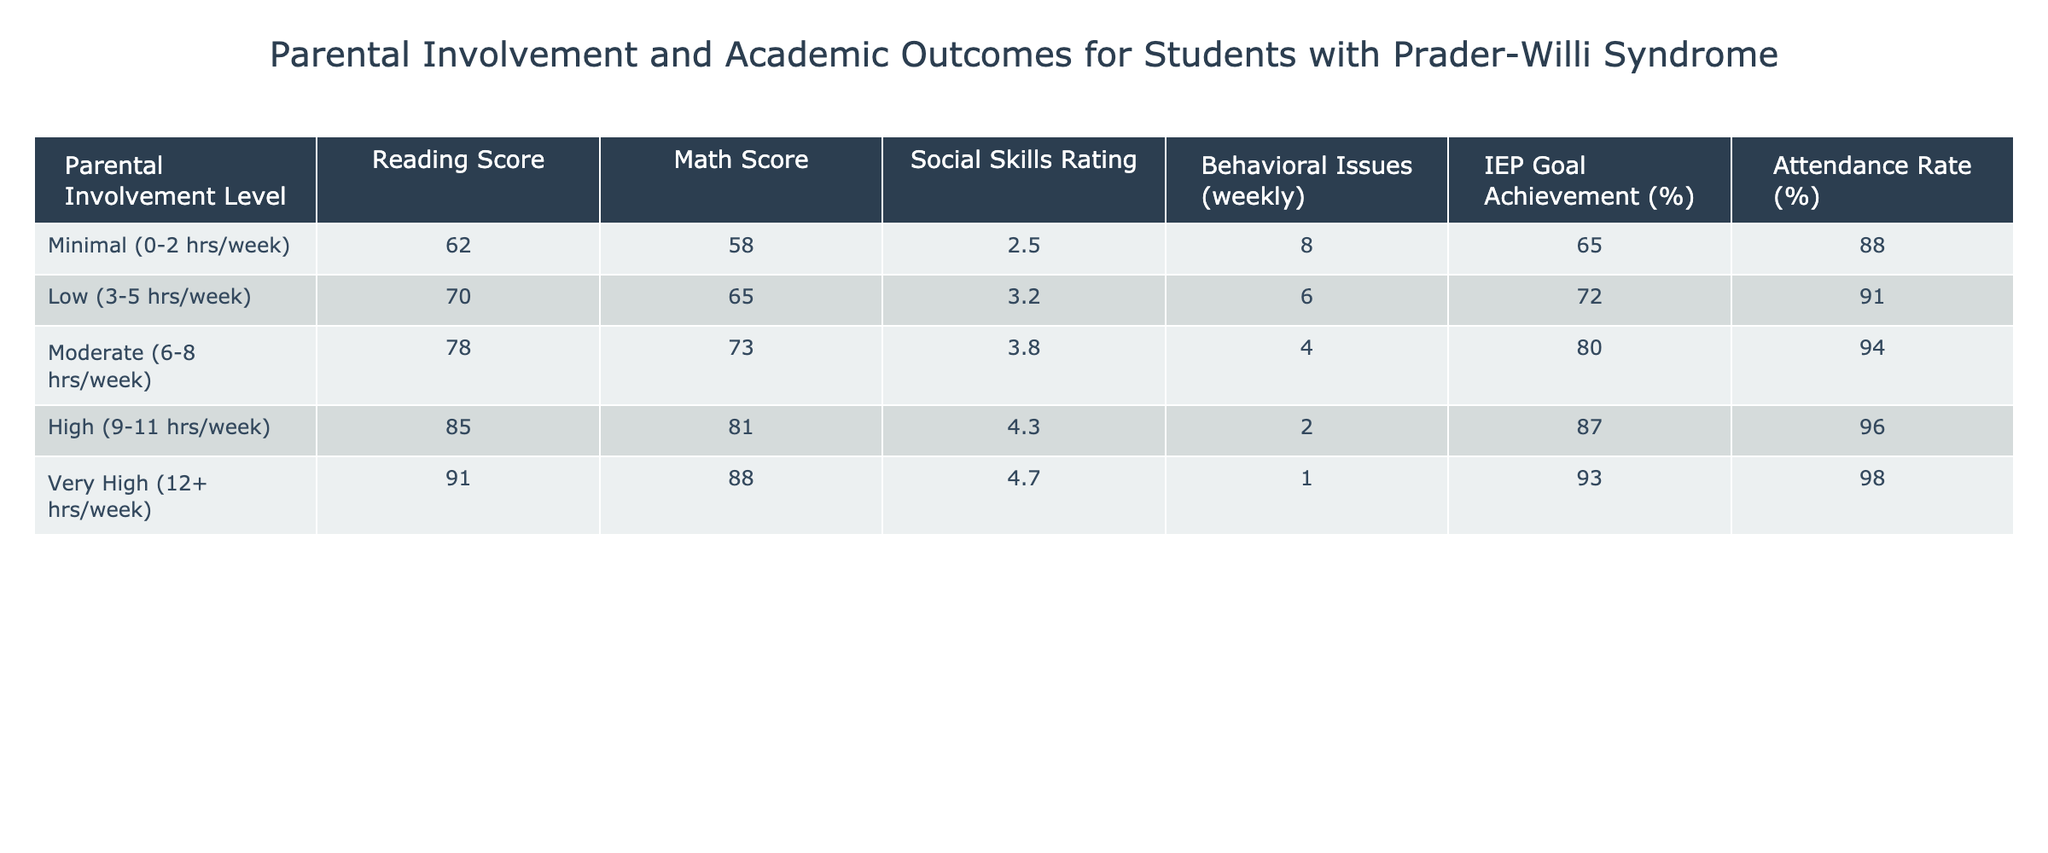What is the Reading Score for the High Parental Involvement Level? The Reading Score corresponding to the High Parental Involvement Level is listed directly in the table, which shows a score of 85.
Answer: 85 How much does the Math Score increase from Moderate to Very High Parental Involvement? The Math Score for Moderate is 73 and for Very High is 88. The difference is 88 - 73 = 15.
Answer: 15 What is the Social Skills Rating for students with Minimal Parental Involvement? According to the table, the Social Skills Rating for students with Minimal Parental Involvement is 2.5.
Answer: 2.5 Is the Attendance Rate higher for students with Very High Parental Involvement compared to those with Minimal Parental Involvement? The Attendance Rate for Very High is 98%, and for Minimal it is 88%. Since 98% is greater than 88%, the statement is true.
Answer: Yes What is the average IEP Goal Achievement percentage for students with High and Very High Parental Involvement? The IEP Goal Achievement percentage for High is 87% and for Very High is 93%. The average is (87 + 93) / 2 = 90%.
Answer: 90% Which level of Parental Involvement has the lowest Behavioral Issues and what is the value? The lowest Behavioral Issues are reported at the Very High Parental Involvement level, with a count of 1 issue weekly.
Answer: 1 By how much does the Social Skills Rating improve as Parental Involvement increases from Low to High? The Social Skills Rating for Low is 3.2 and for High is 4.3. The improvement can be calculated as 4.3 - 3.2 = 1.1.
Answer: 1.1 What is the correlation between Reading Score and Attendance Rate for students with Minimal Parental Involvement? For Minimal Parental Involvement, the Reading Score is 62 and the Attendance Rate is 88%. This indicates a positive trend, as a higher score corresponds with a good attendance percentage.
Answer: Positive trend What is the highest Reading Score recorded, and at what level of Parental Involvement does it occur? The highest Reading Score recorded is 91, which occurs at the Very High Parental Involvement level.
Answer: 91 at Very High What is the total number of Behavioral Issues reported weekly amongst all levels of Parental Involvement? The sum of Behavioral Issues across all levels is 8 + 6 + 4 + 2 + 1 = 21.
Answer: 21 